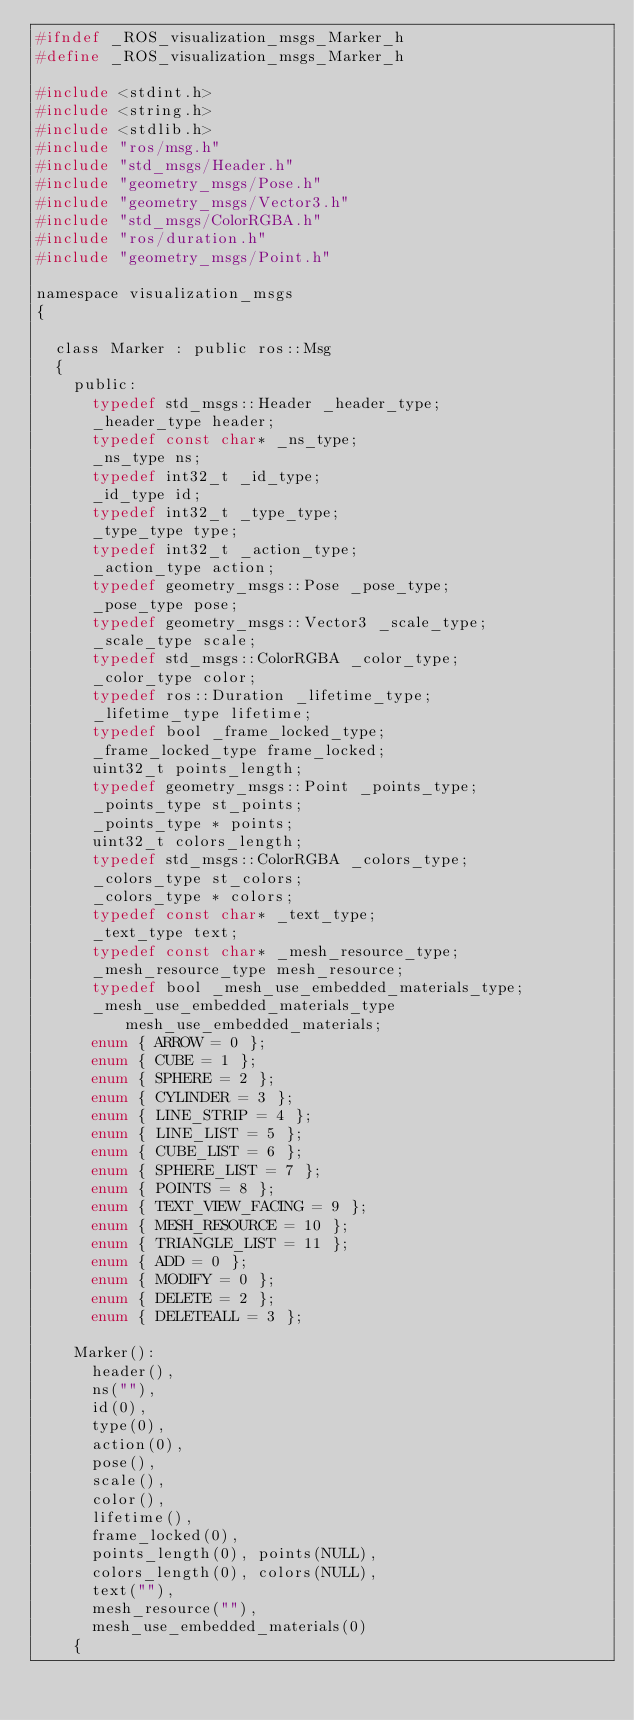Convert code to text. <code><loc_0><loc_0><loc_500><loc_500><_C_>#ifndef _ROS_visualization_msgs_Marker_h
#define _ROS_visualization_msgs_Marker_h

#include <stdint.h>
#include <string.h>
#include <stdlib.h>
#include "ros/msg.h"
#include "std_msgs/Header.h"
#include "geometry_msgs/Pose.h"
#include "geometry_msgs/Vector3.h"
#include "std_msgs/ColorRGBA.h"
#include "ros/duration.h"
#include "geometry_msgs/Point.h"

namespace visualization_msgs
{

  class Marker : public ros::Msg
  {
    public:
      typedef std_msgs::Header _header_type;
      _header_type header;
      typedef const char* _ns_type;
      _ns_type ns;
      typedef int32_t _id_type;
      _id_type id;
      typedef int32_t _type_type;
      _type_type type;
      typedef int32_t _action_type;
      _action_type action;
      typedef geometry_msgs::Pose _pose_type;
      _pose_type pose;
      typedef geometry_msgs::Vector3 _scale_type;
      _scale_type scale;
      typedef std_msgs::ColorRGBA _color_type;
      _color_type color;
      typedef ros::Duration _lifetime_type;
      _lifetime_type lifetime;
      typedef bool _frame_locked_type;
      _frame_locked_type frame_locked;
      uint32_t points_length;
      typedef geometry_msgs::Point _points_type;
      _points_type st_points;
      _points_type * points;
      uint32_t colors_length;
      typedef std_msgs::ColorRGBA _colors_type;
      _colors_type st_colors;
      _colors_type * colors;
      typedef const char* _text_type;
      _text_type text;
      typedef const char* _mesh_resource_type;
      _mesh_resource_type mesh_resource;
      typedef bool _mesh_use_embedded_materials_type;
      _mesh_use_embedded_materials_type mesh_use_embedded_materials;
      enum { ARROW = 0 };
      enum { CUBE = 1 };
      enum { SPHERE = 2 };
      enum { CYLINDER = 3 };
      enum { LINE_STRIP = 4 };
      enum { LINE_LIST = 5 };
      enum { CUBE_LIST = 6 };
      enum { SPHERE_LIST = 7 };
      enum { POINTS = 8 };
      enum { TEXT_VIEW_FACING = 9 };
      enum { MESH_RESOURCE = 10 };
      enum { TRIANGLE_LIST = 11 };
      enum { ADD = 0 };
      enum { MODIFY = 0 };
      enum { DELETE = 2 };
      enum { DELETEALL = 3 };

    Marker():
      header(),
      ns(""),
      id(0),
      type(0),
      action(0),
      pose(),
      scale(),
      color(),
      lifetime(),
      frame_locked(0),
      points_length(0), points(NULL),
      colors_length(0), colors(NULL),
      text(""),
      mesh_resource(""),
      mesh_use_embedded_materials(0)
    {</code> 